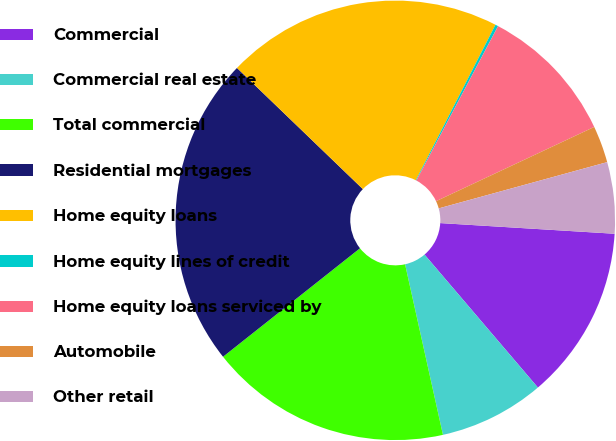Convert chart. <chart><loc_0><loc_0><loc_500><loc_500><pie_chart><fcel>Commercial<fcel>Commercial real estate<fcel>Total commercial<fcel>Residential mortgages<fcel>Home equity loans<fcel>Home equity lines of credit<fcel>Home equity loans serviced by<fcel>Automobile<fcel>Other retail<nl><fcel>12.79%<fcel>7.76%<fcel>17.82%<fcel>22.86%<fcel>20.34%<fcel>0.21%<fcel>10.27%<fcel>2.72%<fcel>5.24%<nl></chart> 